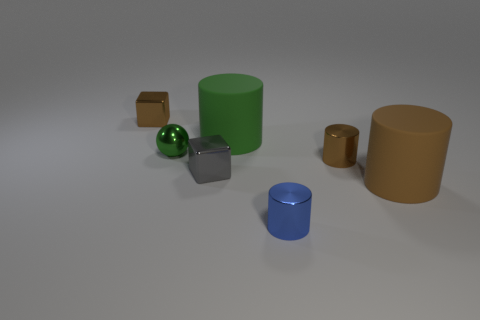What number of other things are the same color as the ball?
Make the answer very short. 1. What is the material of the cylinder that is the same color as the small sphere?
Keep it short and to the point. Rubber. Does the ball have the same color as the large thing left of the brown rubber thing?
Keep it short and to the point. Yes. What color is the small metallic object that is both left of the small blue cylinder and in front of the small green metallic ball?
Your answer should be compact. Gray. How many other objects are there of the same material as the small blue cylinder?
Give a very brief answer. 4. Are there fewer small blue cylinders than large red balls?
Your response must be concise. No. Is the material of the gray cube the same as the large cylinder in front of the green matte cylinder?
Your answer should be very brief. No. The small green metallic object that is on the left side of the large brown matte cylinder has what shape?
Provide a short and direct response. Sphere. Are there any other things that have the same color as the tiny metallic sphere?
Your response must be concise. Yes. Are there fewer green cylinders that are in front of the blue thing than tiny gray shiny things?
Your answer should be compact. Yes. 